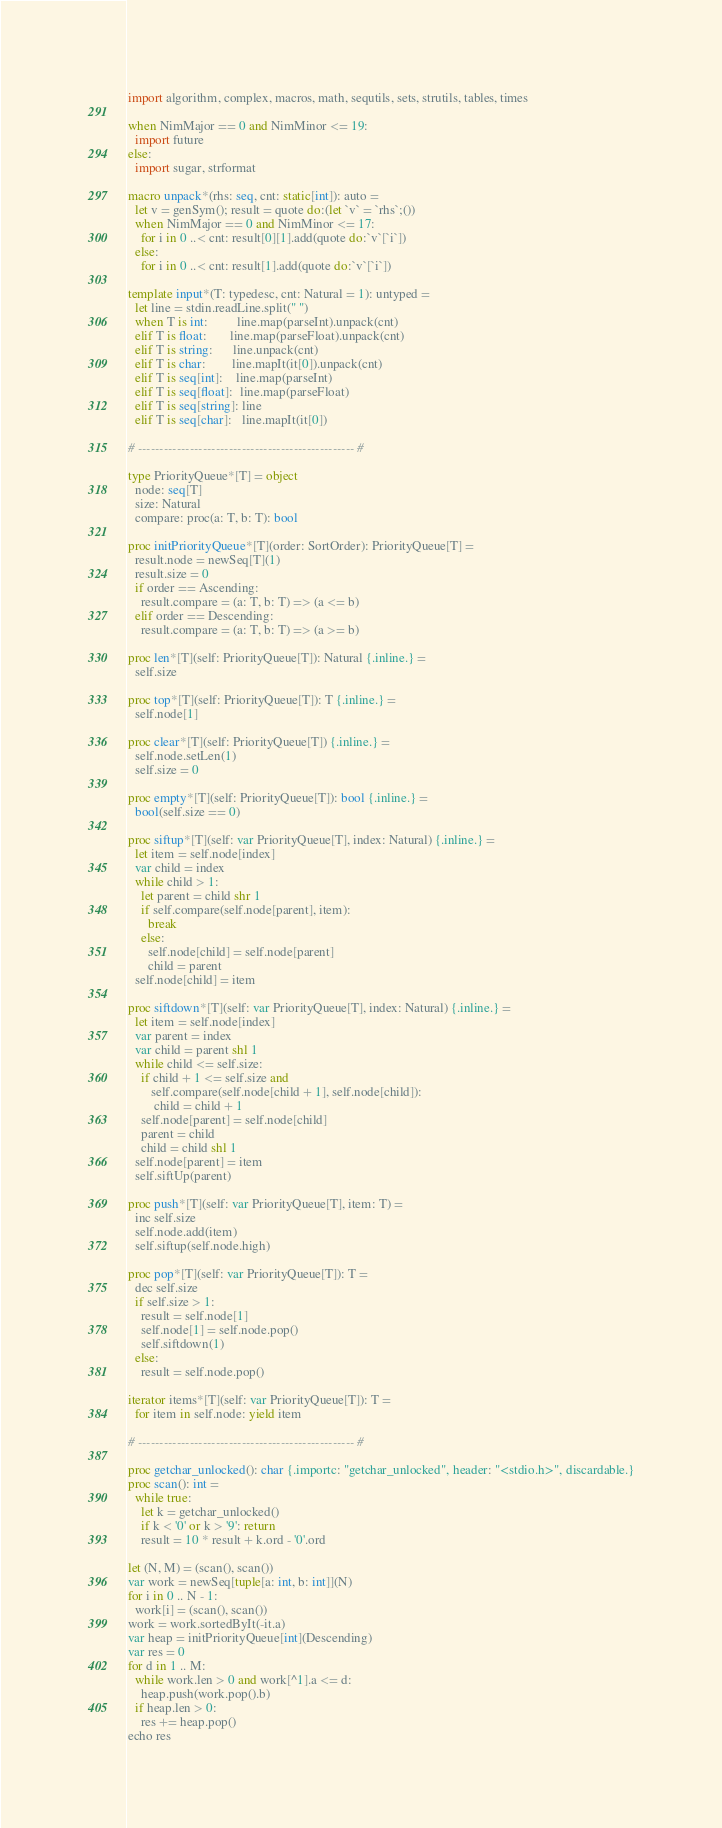Convert code to text. <code><loc_0><loc_0><loc_500><loc_500><_Nim_>import algorithm, complex, macros, math, sequtils, sets, strutils, tables, times

when NimMajor == 0 and NimMinor <= 19:
  import future
else:
  import sugar, strformat

macro unpack*(rhs: seq, cnt: static[int]): auto =
  let v = genSym(); result = quote do:(let `v` = `rhs`;())
  when NimMajor == 0 and NimMinor <= 17:
    for i in 0 ..< cnt: result[0][1].add(quote do:`v`[`i`])
  else:
    for i in 0 ..< cnt: result[1].add(quote do:`v`[`i`])

template input*(T: typedesc, cnt: Natural = 1): untyped =
  let line = stdin.readLine.split(" ")
  when T is int:         line.map(parseInt).unpack(cnt)
  elif T is float:       line.map(parseFloat).unpack(cnt)
  elif T is string:      line.unpack(cnt)
  elif T is char:        line.mapIt(it[0]).unpack(cnt)
  elif T is seq[int]:    line.map(parseInt)
  elif T is seq[float]:  line.map(parseFloat)
  elif T is seq[string]: line
  elif T is seq[char]:   line.mapIt(it[0])

# -------------------------------------------------- #

type PriorityQueue*[T] = object
  node: seq[T]
  size: Natural
  compare: proc(a: T, b: T): bool
 
proc initPriorityQueue*[T](order: SortOrder): PriorityQueue[T] =
  result.node = newSeq[T](1)
  result.size = 0
  if order == Ascending:
    result.compare = (a: T, b: T) => (a <= b)
  elif order == Descending:
    result.compare = (a: T, b: T) => (a >= b)
 
proc len*[T](self: PriorityQueue[T]): Natural {.inline.} =
  self.size
 
proc top*[T](self: PriorityQueue[T]): T {.inline.} =
  self.node[1]
 
proc clear*[T](self: PriorityQueue[T]) {.inline.} =
  self.node.setLen(1)
  self.size = 0
 
proc empty*[T](self: PriorityQueue[T]): bool {.inline.} =
  bool(self.size == 0)
 
proc siftup*[T](self: var PriorityQueue[T], index: Natural) {.inline.} =
  let item = self.node[index]
  var child = index
  while child > 1:
    let parent = child shr 1
    if self.compare(self.node[parent], item):
      break
    else:
      self.node[child] = self.node[parent]
      child = parent
  self.node[child] = item
 
proc siftdown*[T](self: var PriorityQueue[T], index: Natural) {.inline.} =
  let item = self.node[index]
  var parent = index
  var child = parent shl 1
  while child <= self.size:
    if child + 1 <= self.size and 
       self.compare(self.node[child + 1], self.node[child]):
        child = child + 1
    self.node[parent] = self.node[child]
    parent = child
    child = child shl 1
  self.node[parent] = item
  self.siftUp(parent)
 
proc push*[T](self: var PriorityQueue[T], item: T) =
  inc self.size
  self.node.add(item)
  self.siftup(self.node.high)
 
proc pop*[T](self: var PriorityQueue[T]): T =
  dec self.size
  if self.size > 1:
    result = self.node[1]
    self.node[1] = self.node.pop()
    self.siftdown(1)
  else:
    result = self.node.pop()
 
iterator items*[T](self: var PriorityQueue[T]): T =
  for item in self.node: yield item
 
# -------------------------------------------------- #

proc getchar_unlocked(): char {.importc: "getchar_unlocked", header: "<stdio.h>", discardable.}
proc scan(): int =
  while true:
    let k = getchar_unlocked()
    if k < '0' or k > '9': return
    result = 10 * result + k.ord - '0'.ord

let (N, M) = (scan(), scan())
var work = newSeq[tuple[a: int, b: int]](N)
for i in 0 .. N - 1:
  work[i] = (scan(), scan())
work = work.sortedByIt(-it.a)
var heap = initPriorityQueue[int](Descending)
var res = 0
for d in 1 .. M:
  while work.len > 0 and work[^1].a <= d:
    heap.push(work.pop().b)
  if heap.len > 0:
    res += heap.pop()
echo res</code> 